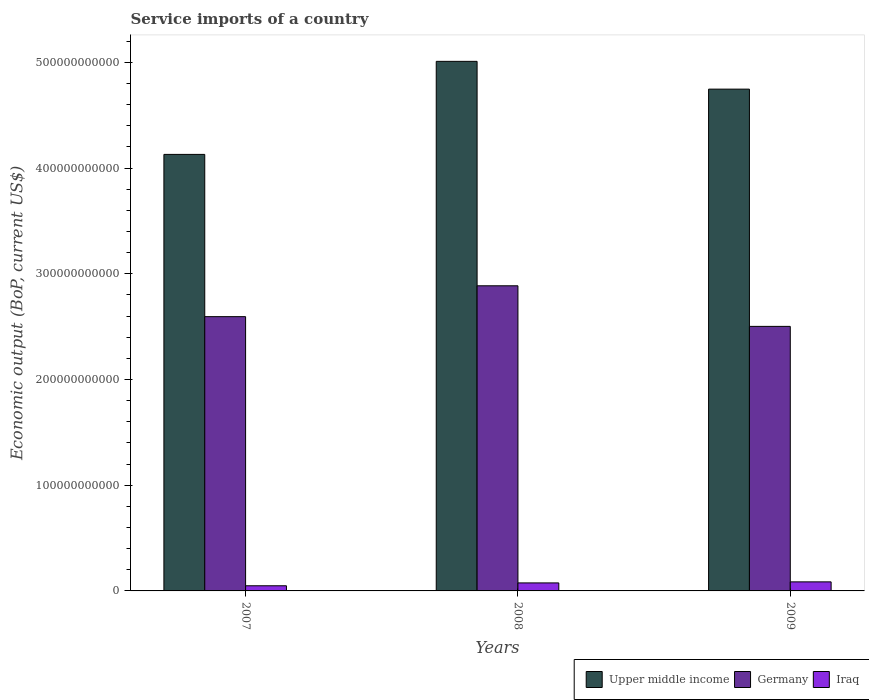Are the number of bars per tick equal to the number of legend labels?
Give a very brief answer. Yes. Are the number of bars on each tick of the X-axis equal?
Keep it short and to the point. Yes. How many bars are there on the 1st tick from the right?
Provide a short and direct response. 3. In how many cases, is the number of bars for a given year not equal to the number of legend labels?
Keep it short and to the point. 0. What is the service imports in Germany in 2008?
Your answer should be compact. 2.89e+11. Across all years, what is the maximum service imports in Germany?
Your answer should be very brief. 2.89e+11. Across all years, what is the minimum service imports in Iraq?
Provide a succinct answer. 4.87e+09. In which year was the service imports in Upper middle income maximum?
Your response must be concise. 2008. In which year was the service imports in Upper middle income minimum?
Your answer should be compact. 2007. What is the total service imports in Iraq in the graph?
Ensure brevity in your answer.  2.10e+1. What is the difference between the service imports in Iraq in 2007 and that in 2009?
Offer a terse response. -3.70e+09. What is the difference between the service imports in Upper middle income in 2008 and the service imports in Iraq in 2007?
Your response must be concise. 4.96e+11. What is the average service imports in Iraq per year?
Provide a short and direct response. 7.00e+09. In the year 2008, what is the difference between the service imports in Upper middle income and service imports in Iraq?
Offer a very short reply. 4.93e+11. In how many years, is the service imports in Iraq greater than 40000000000 US$?
Your answer should be compact. 0. What is the ratio of the service imports in Upper middle income in 2007 to that in 2009?
Your answer should be very brief. 0.87. What is the difference between the highest and the second highest service imports in Germany?
Your answer should be compact. 2.92e+1. What is the difference between the highest and the lowest service imports in Iraq?
Offer a very short reply. 3.70e+09. Is the sum of the service imports in Iraq in 2007 and 2009 greater than the maximum service imports in Germany across all years?
Provide a short and direct response. No. What does the 2nd bar from the left in 2007 represents?
Keep it short and to the point. Germany. What does the 3rd bar from the right in 2007 represents?
Provide a succinct answer. Upper middle income. Is it the case that in every year, the sum of the service imports in Upper middle income and service imports in Germany is greater than the service imports in Iraq?
Provide a short and direct response. Yes. What is the difference between two consecutive major ticks on the Y-axis?
Your response must be concise. 1.00e+11. Does the graph contain any zero values?
Provide a succinct answer. No. Does the graph contain grids?
Ensure brevity in your answer.  No. How are the legend labels stacked?
Your answer should be compact. Horizontal. What is the title of the graph?
Your answer should be very brief. Service imports of a country. What is the label or title of the X-axis?
Provide a short and direct response. Years. What is the label or title of the Y-axis?
Keep it short and to the point. Economic output (BoP, current US$). What is the Economic output (BoP, current US$) in Upper middle income in 2007?
Keep it short and to the point. 4.13e+11. What is the Economic output (BoP, current US$) of Germany in 2007?
Your response must be concise. 2.59e+11. What is the Economic output (BoP, current US$) in Iraq in 2007?
Provide a short and direct response. 4.87e+09. What is the Economic output (BoP, current US$) of Upper middle income in 2008?
Offer a very short reply. 5.01e+11. What is the Economic output (BoP, current US$) in Germany in 2008?
Your answer should be compact. 2.89e+11. What is the Economic output (BoP, current US$) in Iraq in 2008?
Provide a short and direct response. 7.57e+09. What is the Economic output (BoP, current US$) in Upper middle income in 2009?
Give a very brief answer. 4.75e+11. What is the Economic output (BoP, current US$) of Germany in 2009?
Your answer should be very brief. 2.50e+11. What is the Economic output (BoP, current US$) in Iraq in 2009?
Provide a short and direct response. 8.56e+09. Across all years, what is the maximum Economic output (BoP, current US$) of Upper middle income?
Your answer should be very brief. 5.01e+11. Across all years, what is the maximum Economic output (BoP, current US$) in Germany?
Your answer should be compact. 2.89e+11. Across all years, what is the maximum Economic output (BoP, current US$) of Iraq?
Keep it short and to the point. 8.56e+09. Across all years, what is the minimum Economic output (BoP, current US$) of Upper middle income?
Give a very brief answer. 4.13e+11. Across all years, what is the minimum Economic output (BoP, current US$) of Germany?
Provide a succinct answer. 2.50e+11. Across all years, what is the minimum Economic output (BoP, current US$) in Iraq?
Make the answer very short. 4.87e+09. What is the total Economic output (BoP, current US$) in Upper middle income in the graph?
Ensure brevity in your answer.  1.39e+12. What is the total Economic output (BoP, current US$) in Germany in the graph?
Provide a succinct answer. 7.98e+11. What is the total Economic output (BoP, current US$) in Iraq in the graph?
Provide a short and direct response. 2.10e+1. What is the difference between the Economic output (BoP, current US$) of Upper middle income in 2007 and that in 2008?
Your answer should be compact. -8.80e+1. What is the difference between the Economic output (BoP, current US$) of Germany in 2007 and that in 2008?
Offer a terse response. -2.92e+1. What is the difference between the Economic output (BoP, current US$) of Iraq in 2007 and that in 2008?
Ensure brevity in your answer.  -2.71e+09. What is the difference between the Economic output (BoP, current US$) of Upper middle income in 2007 and that in 2009?
Keep it short and to the point. -6.17e+1. What is the difference between the Economic output (BoP, current US$) of Germany in 2007 and that in 2009?
Provide a succinct answer. 9.21e+09. What is the difference between the Economic output (BoP, current US$) in Iraq in 2007 and that in 2009?
Keep it short and to the point. -3.70e+09. What is the difference between the Economic output (BoP, current US$) of Upper middle income in 2008 and that in 2009?
Give a very brief answer. 2.63e+1. What is the difference between the Economic output (BoP, current US$) in Germany in 2008 and that in 2009?
Keep it short and to the point. 3.84e+1. What is the difference between the Economic output (BoP, current US$) in Iraq in 2008 and that in 2009?
Your answer should be compact. -9.91e+08. What is the difference between the Economic output (BoP, current US$) of Upper middle income in 2007 and the Economic output (BoP, current US$) of Germany in 2008?
Offer a very short reply. 1.24e+11. What is the difference between the Economic output (BoP, current US$) in Upper middle income in 2007 and the Economic output (BoP, current US$) in Iraq in 2008?
Offer a very short reply. 4.05e+11. What is the difference between the Economic output (BoP, current US$) of Germany in 2007 and the Economic output (BoP, current US$) of Iraq in 2008?
Provide a succinct answer. 2.52e+11. What is the difference between the Economic output (BoP, current US$) in Upper middle income in 2007 and the Economic output (BoP, current US$) in Germany in 2009?
Give a very brief answer. 1.63e+11. What is the difference between the Economic output (BoP, current US$) in Upper middle income in 2007 and the Economic output (BoP, current US$) in Iraq in 2009?
Your answer should be very brief. 4.04e+11. What is the difference between the Economic output (BoP, current US$) of Germany in 2007 and the Economic output (BoP, current US$) of Iraq in 2009?
Offer a very short reply. 2.51e+11. What is the difference between the Economic output (BoP, current US$) in Upper middle income in 2008 and the Economic output (BoP, current US$) in Germany in 2009?
Provide a short and direct response. 2.51e+11. What is the difference between the Economic output (BoP, current US$) in Upper middle income in 2008 and the Economic output (BoP, current US$) in Iraq in 2009?
Your response must be concise. 4.92e+11. What is the difference between the Economic output (BoP, current US$) in Germany in 2008 and the Economic output (BoP, current US$) in Iraq in 2009?
Ensure brevity in your answer.  2.80e+11. What is the average Economic output (BoP, current US$) of Upper middle income per year?
Provide a short and direct response. 4.63e+11. What is the average Economic output (BoP, current US$) of Germany per year?
Make the answer very short. 2.66e+11. What is the average Economic output (BoP, current US$) of Iraq per year?
Offer a terse response. 7.00e+09. In the year 2007, what is the difference between the Economic output (BoP, current US$) of Upper middle income and Economic output (BoP, current US$) of Germany?
Ensure brevity in your answer.  1.53e+11. In the year 2007, what is the difference between the Economic output (BoP, current US$) in Upper middle income and Economic output (BoP, current US$) in Iraq?
Provide a succinct answer. 4.08e+11. In the year 2007, what is the difference between the Economic output (BoP, current US$) of Germany and Economic output (BoP, current US$) of Iraq?
Your response must be concise. 2.55e+11. In the year 2008, what is the difference between the Economic output (BoP, current US$) of Upper middle income and Economic output (BoP, current US$) of Germany?
Provide a short and direct response. 2.12e+11. In the year 2008, what is the difference between the Economic output (BoP, current US$) in Upper middle income and Economic output (BoP, current US$) in Iraq?
Make the answer very short. 4.93e+11. In the year 2008, what is the difference between the Economic output (BoP, current US$) of Germany and Economic output (BoP, current US$) of Iraq?
Your answer should be compact. 2.81e+11. In the year 2009, what is the difference between the Economic output (BoP, current US$) of Upper middle income and Economic output (BoP, current US$) of Germany?
Your answer should be very brief. 2.24e+11. In the year 2009, what is the difference between the Economic output (BoP, current US$) in Upper middle income and Economic output (BoP, current US$) in Iraq?
Keep it short and to the point. 4.66e+11. In the year 2009, what is the difference between the Economic output (BoP, current US$) in Germany and Economic output (BoP, current US$) in Iraq?
Give a very brief answer. 2.42e+11. What is the ratio of the Economic output (BoP, current US$) in Upper middle income in 2007 to that in 2008?
Offer a terse response. 0.82. What is the ratio of the Economic output (BoP, current US$) in Germany in 2007 to that in 2008?
Your answer should be very brief. 0.9. What is the ratio of the Economic output (BoP, current US$) of Iraq in 2007 to that in 2008?
Your answer should be compact. 0.64. What is the ratio of the Economic output (BoP, current US$) in Upper middle income in 2007 to that in 2009?
Make the answer very short. 0.87. What is the ratio of the Economic output (BoP, current US$) of Germany in 2007 to that in 2009?
Your answer should be very brief. 1.04. What is the ratio of the Economic output (BoP, current US$) in Iraq in 2007 to that in 2009?
Your answer should be very brief. 0.57. What is the ratio of the Economic output (BoP, current US$) in Upper middle income in 2008 to that in 2009?
Your answer should be very brief. 1.06. What is the ratio of the Economic output (BoP, current US$) in Germany in 2008 to that in 2009?
Offer a very short reply. 1.15. What is the ratio of the Economic output (BoP, current US$) in Iraq in 2008 to that in 2009?
Give a very brief answer. 0.88. What is the difference between the highest and the second highest Economic output (BoP, current US$) of Upper middle income?
Provide a succinct answer. 2.63e+1. What is the difference between the highest and the second highest Economic output (BoP, current US$) of Germany?
Give a very brief answer. 2.92e+1. What is the difference between the highest and the second highest Economic output (BoP, current US$) of Iraq?
Offer a terse response. 9.91e+08. What is the difference between the highest and the lowest Economic output (BoP, current US$) in Upper middle income?
Provide a succinct answer. 8.80e+1. What is the difference between the highest and the lowest Economic output (BoP, current US$) in Germany?
Your response must be concise. 3.84e+1. What is the difference between the highest and the lowest Economic output (BoP, current US$) of Iraq?
Offer a very short reply. 3.70e+09. 